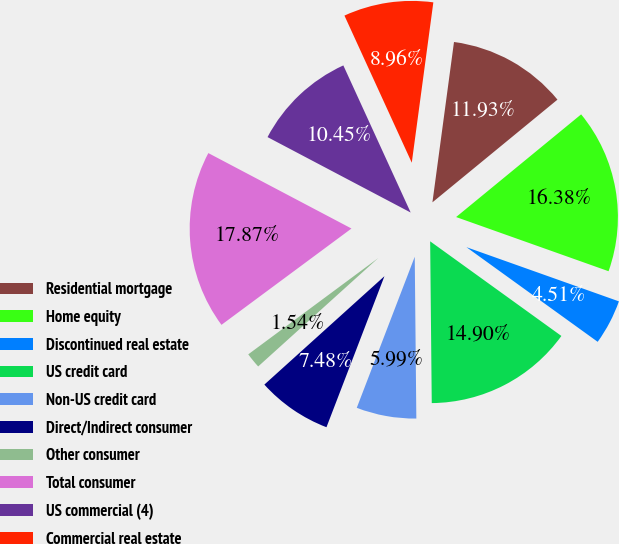Convert chart. <chart><loc_0><loc_0><loc_500><loc_500><pie_chart><fcel>Residential mortgage<fcel>Home equity<fcel>Discontinued real estate<fcel>US credit card<fcel>Non-US credit card<fcel>Direct/Indirect consumer<fcel>Other consumer<fcel>Total consumer<fcel>US commercial (4)<fcel>Commercial real estate<nl><fcel>11.93%<fcel>16.38%<fcel>4.51%<fcel>14.9%<fcel>5.99%<fcel>7.48%<fcel>1.54%<fcel>17.87%<fcel>10.45%<fcel>8.96%<nl></chart> 